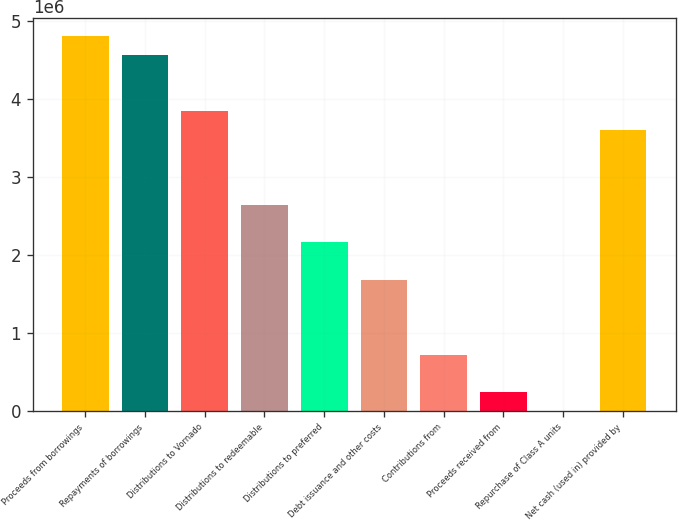<chart> <loc_0><loc_0><loc_500><loc_500><bar_chart><fcel>Proceeds from borrowings<fcel>Repayments of borrowings<fcel>Distributions to Vornado<fcel>Distributions to redeemable<fcel>Distributions to preferred<fcel>Debt issuance and other costs<fcel>Contributions from<fcel>Proceeds received from<fcel>Repurchase of Class A units<fcel>Net cash (used in) provided by<nl><fcel>4.80761e+06<fcel>4.56724e+06<fcel>3.84613e+06<fcel>2.64427e+06<fcel>2.16353e+06<fcel>1.68278e+06<fcel>721300<fcel>240557<fcel>186<fcel>3.60575e+06<nl></chart> 